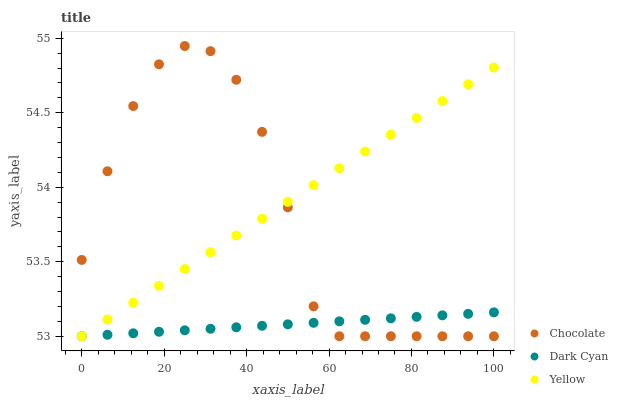Does Dark Cyan have the minimum area under the curve?
Answer yes or no. Yes. Does Yellow have the maximum area under the curve?
Answer yes or no. Yes. Does Chocolate have the minimum area under the curve?
Answer yes or no. No. Does Chocolate have the maximum area under the curve?
Answer yes or no. No. Is Yellow the smoothest?
Answer yes or no. Yes. Is Chocolate the roughest?
Answer yes or no. Yes. Is Chocolate the smoothest?
Answer yes or no. No. Is Yellow the roughest?
Answer yes or no. No. Does Dark Cyan have the lowest value?
Answer yes or no. Yes. Does Chocolate have the highest value?
Answer yes or no. Yes. Does Yellow have the highest value?
Answer yes or no. No. Does Dark Cyan intersect Yellow?
Answer yes or no. Yes. Is Dark Cyan less than Yellow?
Answer yes or no. No. Is Dark Cyan greater than Yellow?
Answer yes or no. No. 